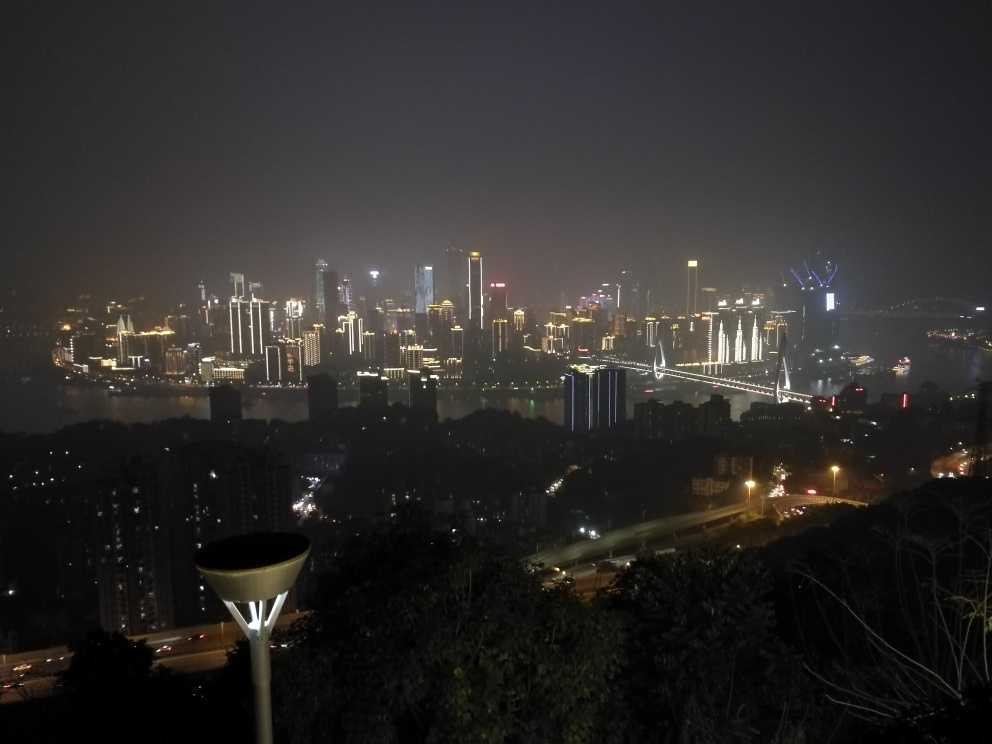Considering the perspective from which this image is taken, what can you infer about the photographer's position in relation to the cityscape? The photographer appears to be positioned at a higher vantage point, overlooking the cityscape. This perspective allows for a sweeping view of the architectural skyline and the river and suggests that the photo was likely taken from a hill, building, or other elevated area. The angle offers a comprehensive overlook, providing a sense of scale and grandeur to the urban setting and emphasizing the vastness of the city. 